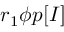<formula> <loc_0><loc_0><loc_500><loc_500>r _ { 1 } \phi p [ I ]</formula> 